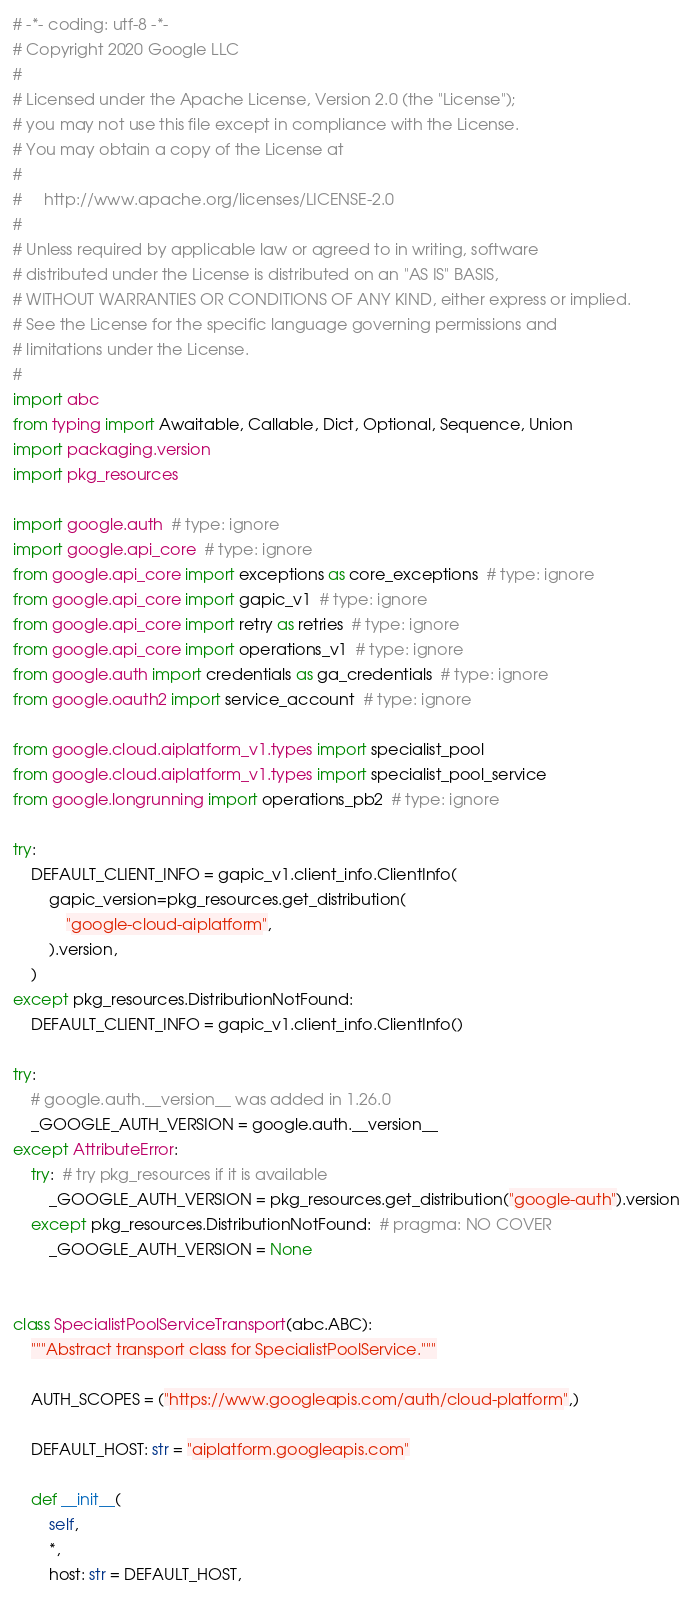Convert code to text. <code><loc_0><loc_0><loc_500><loc_500><_Python_># -*- coding: utf-8 -*-
# Copyright 2020 Google LLC
#
# Licensed under the Apache License, Version 2.0 (the "License");
# you may not use this file except in compliance with the License.
# You may obtain a copy of the License at
#
#     http://www.apache.org/licenses/LICENSE-2.0
#
# Unless required by applicable law or agreed to in writing, software
# distributed under the License is distributed on an "AS IS" BASIS,
# WITHOUT WARRANTIES OR CONDITIONS OF ANY KIND, either express or implied.
# See the License for the specific language governing permissions and
# limitations under the License.
#
import abc
from typing import Awaitable, Callable, Dict, Optional, Sequence, Union
import packaging.version
import pkg_resources

import google.auth  # type: ignore
import google.api_core  # type: ignore
from google.api_core import exceptions as core_exceptions  # type: ignore
from google.api_core import gapic_v1  # type: ignore
from google.api_core import retry as retries  # type: ignore
from google.api_core import operations_v1  # type: ignore
from google.auth import credentials as ga_credentials  # type: ignore
from google.oauth2 import service_account  # type: ignore

from google.cloud.aiplatform_v1.types import specialist_pool
from google.cloud.aiplatform_v1.types import specialist_pool_service
from google.longrunning import operations_pb2  # type: ignore

try:
    DEFAULT_CLIENT_INFO = gapic_v1.client_info.ClientInfo(
        gapic_version=pkg_resources.get_distribution(
            "google-cloud-aiplatform",
        ).version,
    )
except pkg_resources.DistributionNotFound:
    DEFAULT_CLIENT_INFO = gapic_v1.client_info.ClientInfo()

try:
    # google.auth.__version__ was added in 1.26.0
    _GOOGLE_AUTH_VERSION = google.auth.__version__
except AttributeError:
    try:  # try pkg_resources if it is available
        _GOOGLE_AUTH_VERSION = pkg_resources.get_distribution("google-auth").version
    except pkg_resources.DistributionNotFound:  # pragma: NO COVER
        _GOOGLE_AUTH_VERSION = None


class SpecialistPoolServiceTransport(abc.ABC):
    """Abstract transport class for SpecialistPoolService."""

    AUTH_SCOPES = ("https://www.googleapis.com/auth/cloud-platform",)

    DEFAULT_HOST: str = "aiplatform.googleapis.com"

    def __init__(
        self,
        *,
        host: str = DEFAULT_HOST,</code> 